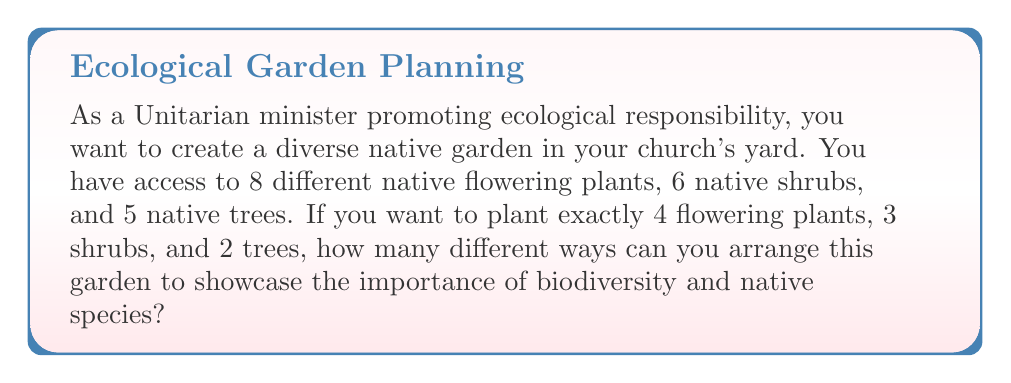Can you solve this math problem? To solve this problem, we need to use the combination formula from discrete mathematics. We're selecting a specific number of plants from each category without repetition and where the order doesn't matter.

1. For flowering plants: We're choosing 4 out of 8.
   $${8 \choose 4} = \frac{8!}{4!(8-4)!} = \frac{8!}{4!4!}$$

2. For shrubs: We're choosing 3 out of 6.
   $${6 \choose 3} = \frac{6!}{3!(6-3)!} = \frac{6!}{3!3!}$$

3. For trees: We're choosing 2 out of 5.
   $${5 \choose 2} = \frac{5!}{2!(5-2)!} = \frac{5!}{2!3!}$$

Now, we apply the multiplication principle. The total number of ways to arrange the garden is the product of these three combinations:

$${8 \choose 4} \cdot {6 \choose 3} \cdot {5 \choose 2}$$

Let's calculate each combination:

$${8 \choose 4} = \frac{8 \cdot 7 \cdot 6 \cdot 5}{4 \cdot 3 \cdot 2 \cdot 1} = 70$$

$${6 \choose 3} = \frac{6 \cdot 5 \cdot 4}{3 \cdot 2 \cdot 1} = 20$$

$${5 \choose 2} = \frac{5 \cdot 4}{2 \cdot 1} = 10$$

Therefore, the total number of ways is:

$$70 \cdot 20 \cdot 10 = 14,000$$
Answer: 14,000 ways 